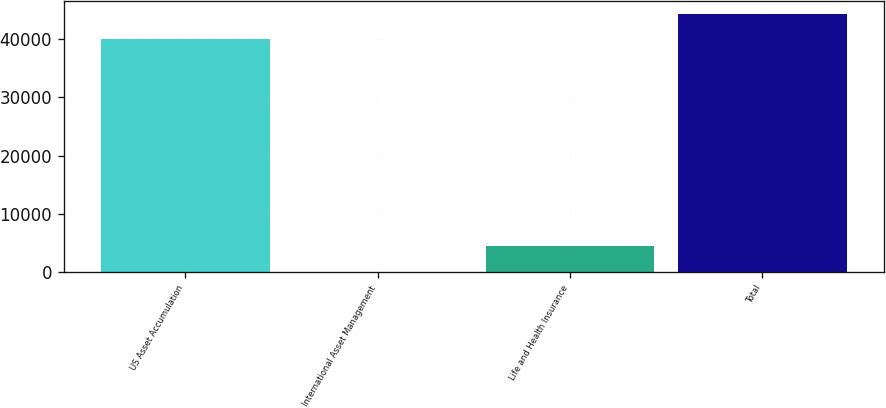<chart> <loc_0><loc_0><loc_500><loc_500><bar_chart><fcel>US Asset Accumulation<fcel>International Asset Management<fcel>Life and Health Insurance<fcel>Total<nl><fcel>39983.6<fcel>57.9<fcel>4414.39<fcel>44340.1<nl></chart> 